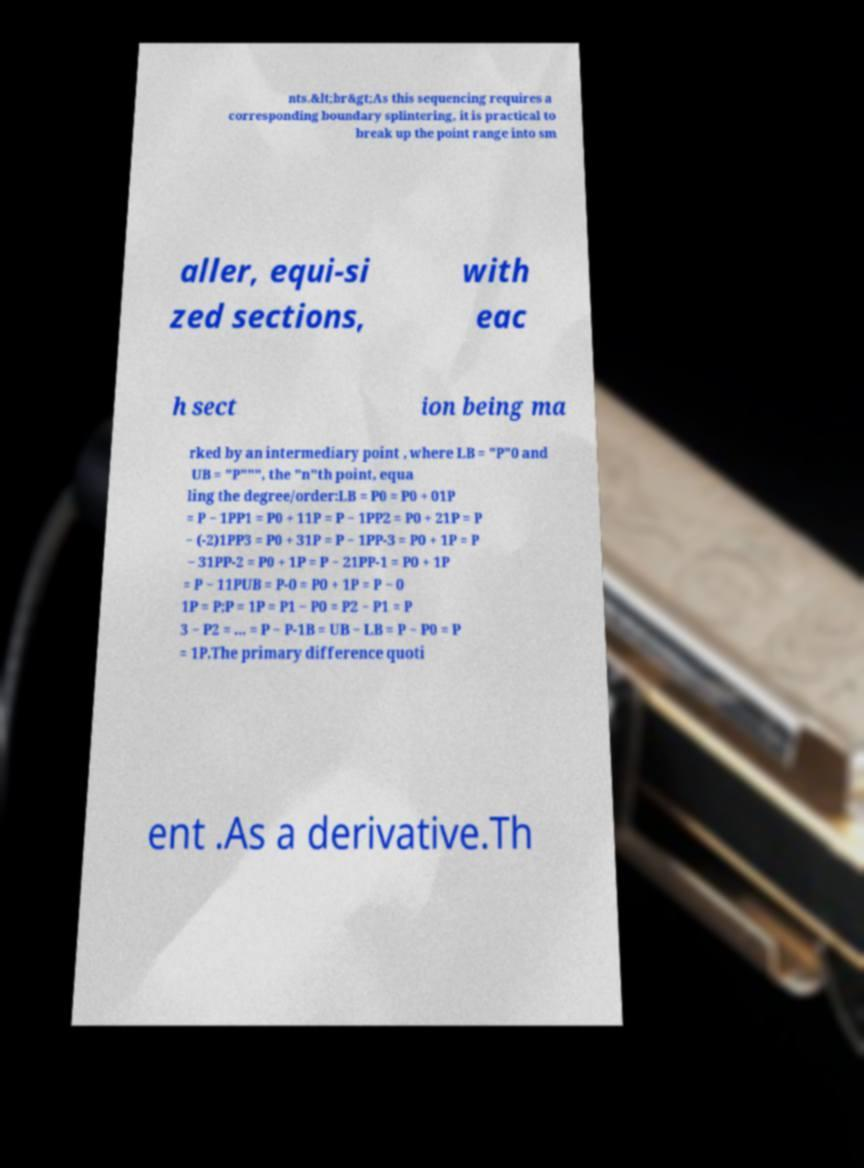Could you extract and type out the text from this image? nts.&lt;br&gt;As this sequencing requires a corresponding boundary splintering, it is practical to break up the point range into sm aller, equi-si zed sections, with eac h sect ion being ma rked by an intermediary point , where LB = "P"0 and UB = "P""", the "n"th point, equa ling the degree/order:LB = P0 = P0 + 01P = P − 1PP1 = P0 + 11P = P − 1PP2 = P0 + 21P = P − (-2)1PP3 = P0 + 31P = P − 1PP-3 = P0 + 1P = P − 31PP-2 = P0 + 1P = P − 21PP-1 = P0 + 1P = P − 11PUB = P-0 = P0 + 1P = P − 0 1P = P;P = 1P = P1 − P0 = P2 − P1 = P 3 − P2 = ... = P − P-1B = UB − LB = P − P0 = P = 1P.The primary difference quoti ent .As a derivative.Th 